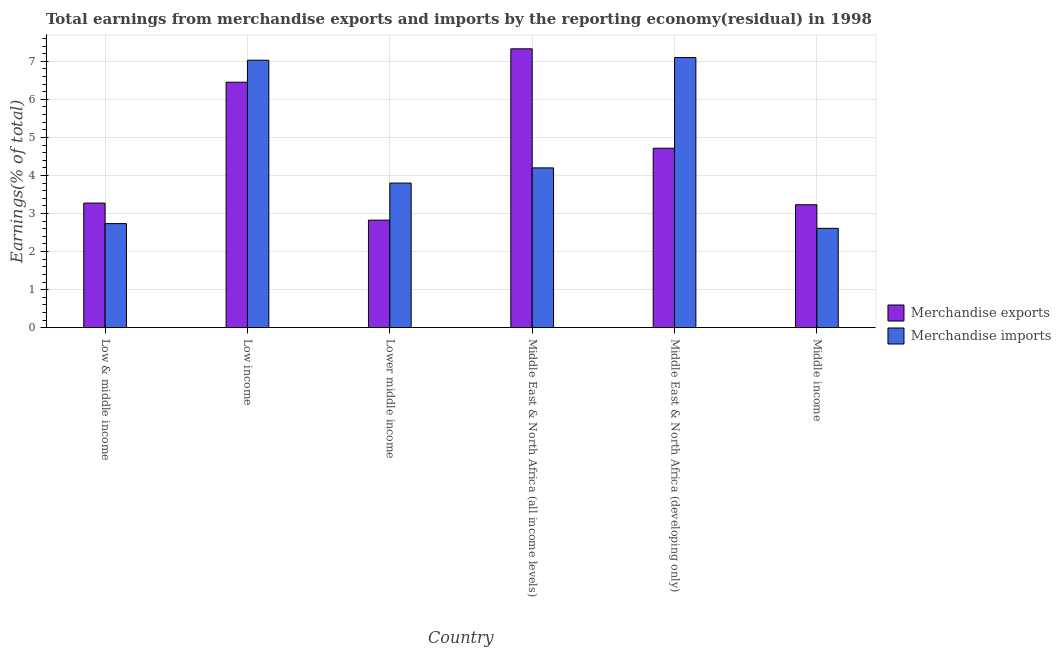How many different coloured bars are there?
Your answer should be very brief. 2. How many groups of bars are there?
Give a very brief answer. 6. Are the number of bars on each tick of the X-axis equal?
Make the answer very short. Yes. How many bars are there on the 4th tick from the left?
Offer a terse response. 2. What is the label of the 3rd group of bars from the left?
Your answer should be very brief. Lower middle income. What is the earnings from merchandise imports in Lower middle income?
Keep it short and to the point. 3.8. Across all countries, what is the maximum earnings from merchandise exports?
Keep it short and to the point. 7.33. Across all countries, what is the minimum earnings from merchandise imports?
Offer a terse response. 2.61. In which country was the earnings from merchandise exports maximum?
Your answer should be very brief. Middle East & North Africa (all income levels). In which country was the earnings from merchandise exports minimum?
Give a very brief answer. Lower middle income. What is the total earnings from merchandise exports in the graph?
Make the answer very short. 27.82. What is the difference between the earnings from merchandise imports in Low income and that in Middle East & North Africa (developing only)?
Your response must be concise. -0.07. What is the difference between the earnings from merchandise imports in Low income and the earnings from merchandise exports in Low & middle income?
Provide a succinct answer. 3.75. What is the average earnings from merchandise imports per country?
Give a very brief answer. 4.58. What is the difference between the earnings from merchandise exports and earnings from merchandise imports in Middle East & North Africa (developing only)?
Provide a short and direct response. -2.38. In how many countries, is the earnings from merchandise exports greater than 0.2 %?
Offer a very short reply. 6. What is the ratio of the earnings from merchandise exports in Lower middle income to that in Middle East & North Africa (all income levels)?
Your response must be concise. 0.39. Is the difference between the earnings from merchandise imports in Lower middle income and Middle East & North Africa (all income levels) greater than the difference between the earnings from merchandise exports in Lower middle income and Middle East & North Africa (all income levels)?
Provide a short and direct response. Yes. What is the difference between the highest and the second highest earnings from merchandise exports?
Make the answer very short. 0.88. What is the difference between the highest and the lowest earnings from merchandise exports?
Keep it short and to the point. 4.5. In how many countries, is the earnings from merchandise imports greater than the average earnings from merchandise imports taken over all countries?
Provide a short and direct response. 2. Is the sum of the earnings from merchandise imports in Low income and Middle income greater than the maximum earnings from merchandise exports across all countries?
Your response must be concise. Yes. What does the 1st bar from the right in Middle income represents?
Offer a very short reply. Merchandise imports. How many bars are there?
Make the answer very short. 12. Are all the bars in the graph horizontal?
Provide a succinct answer. No. Are the values on the major ticks of Y-axis written in scientific E-notation?
Your response must be concise. No. Does the graph contain any zero values?
Offer a terse response. No. Does the graph contain grids?
Give a very brief answer. Yes. Where does the legend appear in the graph?
Provide a short and direct response. Center right. What is the title of the graph?
Your response must be concise. Total earnings from merchandise exports and imports by the reporting economy(residual) in 1998. Does "Secondary education" appear as one of the legend labels in the graph?
Provide a succinct answer. No. What is the label or title of the Y-axis?
Keep it short and to the point. Earnings(% of total). What is the Earnings(% of total) of Merchandise exports in Low & middle income?
Make the answer very short. 3.27. What is the Earnings(% of total) of Merchandise imports in Low & middle income?
Make the answer very short. 2.73. What is the Earnings(% of total) of Merchandise exports in Low income?
Your answer should be very brief. 6.45. What is the Earnings(% of total) of Merchandise imports in Low income?
Offer a terse response. 7.03. What is the Earnings(% of total) in Merchandise exports in Lower middle income?
Your answer should be compact. 2.83. What is the Earnings(% of total) of Merchandise imports in Lower middle income?
Ensure brevity in your answer.  3.8. What is the Earnings(% of total) in Merchandise exports in Middle East & North Africa (all income levels)?
Make the answer very short. 7.33. What is the Earnings(% of total) in Merchandise imports in Middle East & North Africa (all income levels)?
Provide a succinct answer. 4.2. What is the Earnings(% of total) of Merchandise exports in Middle East & North Africa (developing only)?
Your answer should be very brief. 4.72. What is the Earnings(% of total) in Merchandise imports in Middle East & North Africa (developing only)?
Ensure brevity in your answer.  7.1. What is the Earnings(% of total) of Merchandise exports in Middle income?
Your answer should be compact. 3.23. What is the Earnings(% of total) in Merchandise imports in Middle income?
Offer a terse response. 2.61. Across all countries, what is the maximum Earnings(% of total) of Merchandise exports?
Provide a succinct answer. 7.33. Across all countries, what is the maximum Earnings(% of total) in Merchandise imports?
Your answer should be compact. 7.1. Across all countries, what is the minimum Earnings(% of total) in Merchandise exports?
Make the answer very short. 2.83. Across all countries, what is the minimum Earnings(% of total) of Merchandise imports?
Your answer should be compact. 2.61. What is the total Earnings(% of total) in Merchandise exports in the graph?
Provide a short and direct response. 27.82. What is the total Earnings(% of total) of Merchandise imports in the graph?
Your response must be concise. 27.47. What is the difference between the Earnings(% of total) in Merchandise exports in Low & middle income and that in Low income?
Keep it short and to the point. -3.18. What is the difference between the Earnings(% of total) of Merchandise imports in Low & middle income and that in Low income?
Give a very brief answer. -4.29. What is the difference between the Earnings(% of total) in Merchandise exports in Low & middle income and that in Lower middle income?
Your response must be concise. 0.45. What is the difference between the Earnings(% of total) of Merchandise imports in Low & middle income and that in Lower middle income?
Keep it short and to the point. -1.07. What is the difference between the Earnings(% of total) in Merchandise exports in Low & middle income and that in Middle East & North Africa (all income levels)?
Your answer should be very brief. -4.05. What is the difference between the Earnings(% of total) of Merchandise imports in Low & middle income and that in Middle East & North Africa (all income levels)?
Offer a very short reply. -1.46. What is the difference between the Earnings(% of total) in Merchandise exports in Low & middle income and that in Middle East & North Africa (developing only)?
Your answer should be very brief. -1.44. What is the difference between the Earnings(% of total) of Merchandise imports in Low & middle income and that in Middle East & North Africa (developing only)?
Your answer should be very brief. -4.36. What is the difference between the Earnings(% of total) in Merchandise exports in Low & middle income and that in Middle income?
Ensure brevity in your answer.  0.04. What is the difference between the Earnings(% of total) of Merchandise imports in Low & middle income and that in Middle income?
Give a very brief answer. 0.12. What is the difference between the Earnings(% of total) in Merchandise exports in Low income and that in Lower middle income?
Provide a succinct answer. 3.63. What is the difference between the Earnings(% of total) of Merchandise imports in Low income and that in Lower middle income?
Give a very brief answer. 3.23. What is the difference between the Earnings(% of total) of Merchandise exports in Low income and that in Middle East & North Africa (all income levels)?
Ensure brevity in your answer.  -0.88. What is the difference between the Earnings(% of total) in Merchandise imports in Low income and that in Middle East & North Africa (all income levels)?
Keep it short and to the point. 2.83. What is the difference between the Earnings(% of total) of Merchandise exports in Low income and that in Middle East & North Africa (developing only)?
Your answer should be compact. 1.74. What is the difference between the Earnings(% of total) of Merchandise imports in Low income and that in Middle East & North Africa (developing only)?
Keep it short and to the point. -0.07. What is the difference between the Earnings(% of total) of Merchandise exports in Low income and that in Middle income?
Your answer should be very brief. 3.22. What is the difference between the Earnings(% of total) in Merchandise imports in Low income and that in Middle income?
Provide a short and direct response. 4.42. What is the difference between the Earnings(% of total) in Merchandise exports in Lower middle income and that in Middle East & North Africa (all income levels)?
Your answer should be very brief. -4.5. What is the difference between the Earnings(% of total) of Merchandise imports in Lower middle income and that in Middle East & North Africa (all income levels)?
Your response must be concise. -0.4. What is the difference between the Earnings(% of total) of Merchandise exports in Lower middle income and that in Middle East & North Africa (developing only)?
Give a very brief answer. -1.89. What is the difference between the Earnings(% of total) of Merchandise imports in Lower middle income and that in Middle East & North Africa (developing only)?
Offer a very short reply. -3.3. What is the difference between the Earnings(% of total) of Merchandise exports in Lower middle income and that in Middle income?
Keep it short and to the point. -0.41. What is the difference between the Earnings(% of total) in Merchandise imports in Lower middle income and that in Middle income?
Your response must be concise. 1.19. What is the difference between the Earnings(% of total) of Merchandise exports in Middle East & North Africa (all income levels) and that in Middle East & North Africa (developing only)?
Offer a terse response. 2.61. What is the difference between the Earnings(% of total) of Merchandise imports in Middle East & North Africa (all income levels) and that in Middle East & North Africa (developing only)?
Ensure brevity in your answer.  -2.9. What is the difference between the Earnings(% of total) in Merchandise exports in Middle East & North Africa (all income levels) and that in Middle income?
Your answer should be very brief. 4.1. What is the difference between the Earnings(% of total) in Merchandise imports in Middle East & North Africa (all income levels) and that in Middle income?
Your answer should be very brief. 1.59. What is the difference between the Earnings(% of total) of Merchandise exports in Middle East & North Africa (developing only) and that in Middle income?
Your answer should be compact. 1.48. What is the difference between the Earnings(% of total) in Merchandise imports in Middle East & North Africa (developing only) and that in Middle income?
Your response must be concise. 4.49. What is the difference between the Earnings(% of total) of Merchandise exports in Low & middle income and the Earnings(% of total) of Merchandise imports in Low income?
Make the answer very short. -3.75. What is the difference between the Earnings(% of total) in Merchandise exports in Low & middle income and the Earnings(% of total) in Merchandise imports in Lower middle income?
Ensure brevity in your answer.  -0.53. What is the difference between the Earnings(% of total) of Merchandise exports in Low & middle income and the Earnings(% of total) of Merchandise imports in Middle East & North Africa (all income levels)?
Keep it short and to the point. -0.92. What is the difference between the Earnings(% of total) of Merchandise exports in Low & middle income and the Earnings(% of total) of Merchandise imports in Middle East & North Africa (developing only)?
Your answer should be very brief. -3.82. What is the difference between the Earnings(% of total) of Merchandise exports in Low & middle income and the Earnings(% of total) of Merchandise imports in Middle income?
Give a very brief answer. 0.66. What is the difference between the Earnings(% of total) in Merchandise exports in Low income and the Earnings(% of total) in Merchandise imports in Lower middle income?
Your answer should be compact. 2.65. What is the difference between the Earnings(% of total) in Merchandise exports in Low income and the Earnings(% of total) in Merchandise imports in Middle East & North Africa (all income levels)?
Make the answer very short. 2.25. What is the difference between the Earnings(% of total) in Merchandise exports in Low income and the Earnings(% of total) in Merchandise imports in Middle East & North Africa (developing only)?
Give a very brief answer. -0.65. What is the difference between the Earnings(% of total) in Merchandise exports in Low income and the Earnings(% of total) in Merchandise imports in Middle income?
Offer a very short reply. 3.84. What is the difference between the Earnings(% of total) in Merchandise exports in Lower middle income and the Earnings(% of total) in Merchandise imports in Middle East & North Africa (all income levels)?
Give a very brief answer. -1.37. What is the difference between the Earnings(% of total) in Merchandise exports in Lower middle income and the Earnings(% of total) in Merchandise imports in Middle East & North Africa (developing only)?
Keep it short and to the point. -4.27. What is the difference between the Earnings(% of total) in Merchandise exports in Lower middle income and the Earnings(% of total) in Merchandise imports in Middle income?
Keep it short and to the point. 0.22. What is the difference between the Earnings(% of total) in Merchandise exports in Middle East & North Africa (all income levels) and the Earnings(% of total) in Merchandise imports in Middle East & North Africa (developing only)?
Your answer should be compact. 0.23. What is the difference between the Earnings(% of total) in Merchandise exports in Middle East & North Africa (all income levels) and the Earnings(% of total) in Merchandise imports in Middle income?
Make the answer very short. 4.72. What is the difference between the Earnings(% of total) of Merchandise exports in Middle East & North Africa (developing only) and the Earnings(% of total) of Merchandise imports in Middle income?
Offer a terse response. 2.1. What is the average Earnings(% of total) in Merchandise exports per country?
Give a very brief answer. 4.64. What is the average Earnings(% of total) in Merchandise imports per country?
Give a very brief answer. 4.58. What is the difference between the Earnings(% of total) of Merchandise exports and Earnings(% of total) of Merchandise imports in Low & middle income?
Ensure brevity in your answer.  0.54. What is the difference between the Earnings(% of total) in Merchandise exports and Earnings(% of total) in Merchandise imports in Low income?
Make the answer very short. -0.58. What is the difference between the Earnings(% of total) in Merchandise exports and Earnings(% of total) in Merchandise imports in Lower middle income?
Keep it short and to the point. -0.97. What is the difference between the Earnings(% of total) of Merchandise exports and Earnings(% of total) of Merchandise imports in Middle East & North Africa (all income levels)?
Provide a succinct answer. 3.13. What is the difference between the Earnings(% of total) of Merchandise exports and Earnings(% of total) of Merchandise imports in Middle East & North Africa (developing only)?
Give a very brief answer. -2.38. What is the difference between the Earnings(% of total) of Merchandise exports and Earnings(% of total) of Merchandise imports in Middle income?
Provide a short and direct response. 0.62. What is the ratio of the Earnings(% of total) in Merchandise exports in Low & middle income to that in Low income?
Your response must be concise. 0.51. What is the ratio of the Earnings(% of total) in Merchandise imports in Low & middle income to that in Low income?
Give a very brief answer. 0.39. What is the ratio of the Earnings(% of total) of Merchandise exports in Low & middle income to that in Lower middle income?
Ensure brevity in your answer.  1.16. What is the ratio of the Earnings(% of total) in Merchandise imports in Low & middle income to that in Lower middle income?
Your response must be concise. 0.72. What is the ratio of the Earnings(% of total) in Merchandise exports in Low & middle income to that in Middle East & North Africa (all income levels)?
Provide a short and direct response. 0.45. What is the ratio of the Earnings(% of total) of Merchandise imports in Low & middle income to that in Middle East & North Africa (all income levels)?
Offer a very short reply. 0.65. What is the ratio of the Earnings(% of total) in Merchandise exports in Low & middle income to that in Middle East & North Africa (developing only)?
Provide a succinct answer. 0.69. What is the ratio of the Earnings(% of total) of Merchandise imports in Low & middle income to that in Middle East & North Africa (developing only)?
Keep it short and to the point. 0.39. What is the ratio of the Earnings(% of total) in Merchandise exports in Low & middle income to that in Middle income?
Keep it short and to the point. 1.01. What is the ratio of the Earnings(% of total) in Merchandise imports in Low & middle income to that in Middle income?
Offer a terse response. 1.05. What is the ratio of the Earnings(% of total) of Merchandise exports in Low income to that in Lower middle income?
Offer a very short reply. 2.28. What is the ratio of the Earnings(% of total) in Merchandise imports in Low income to that in Lower middle income?
Ensure brevity in your answer.  1.85. What is the ratio of the Earnings(% of total) of Merchandise exports in Low income to that in Middle East & North Africa (all income levels)?
Ensure brevity in your answer.  0.88. What is the ratio of the Earnings(% of total) of Merchandise imports in Low income to that in Middle East & North Africa (all income levels)?
Your response must be concise. 1.67. What is the ratio of the Earnings(% of total) in Merchandise exports in Low income to that in Middle East & North Africa (developing only)?
Provide a succinct answer. 1.37. What is the ratio of the Earnings(% of total) in Merchandise imports in Low income to that in Middle East & North Africa (developing only)?
Keep it short and to the point. 0.99. What is the ratio of the Earnings(% of total) of Merchandise exports in Low income to that in Middle income?
Give a very brief answer. 2. What is the ratio of the Earnings(% of total) in Merchandise imports in Low income to that in Middle income?
Ensure brevity in your answer.  2.69. What is the ratio of the Earnings(% of total) of Merchandise exports in Lower middle income to that in Middle East & North Africa (all income levels)?
Provide a succinct answer. 0.39. What is the ratio of the Earnings(% of total) of Merchandise imports in Lower middle income to that in Middle East & North Africa (all income levels)?
Give a very brief answer. 0.91. What is the ratio of the Earnings(% of total) in Merchandise exports in Lower middle income to that in Middle East & North Africa (developing only)?
Your answer should be compact. 0.6. What is the ratio of the Earnings(% of total) in Merchandise imports in Lower middle income to that in Middle East & North Africa (developing only)?
Your answer should be very brief. 0.54. What is the ratio of the Earnings(% of total) of Merchandise exports in Lower middle income to that in Middle income?
Offer a very short reply. 0.87. What is the ratio of the Earnings(% of total) of Merchandise imports in Lower middle income to that in Middle income?
Give a very brief answer. 1.46. What is the ratio of the Earnings(% of total) in Merchandise exports in Middle East & North Africa (all income levels) to that in Middle East & North Africa (developing only)?
Ensure brevity in your answer.  1.55. What is the ratio of the Earnings(% of total) in Merchandise imports in Middle East & North Africa (all income levels) to that in Middle East & North Africa (developing only)?
Offer a very short reply. 0.59. What is the ratio of the Earnings(% of total) of Merchandise exports in Middle East & North Africa (all income levels) to that in Middle income?
Your answer should be compact. 2.27. What is the ratio of the Earnings(% of total) of Merchandise imports in Middle East & North Africa (all income levels) to that in Middle income?
Your answer should be compact. 1.61. What is the ratio of the Earnings(% of total) of Merchandise exports in Middle East & North Africa (developing only) to that in Middle income?
Provide a short and direct response. 1.46. What is the ratio of the Earnings(% of total) of Merchandise imports in Middle East & North Africa (developing only) to that in Middle income?
Give a very brief answer. 2.72. What is the difference between the highest and the second highest Earnings(% of total) of Merchandise exports?
Give a very brief answer. 0.88. What is the difference between the highest and the second highest Earnings(% of total) in Merchandise imports?
Keep it short and to the point. 0.07. What is the difference between the highest and the lowest Earnings(% of total) of Merchandise exports?
Provide a short and direct response. 4.5. What is the difference between the highest and the lowest Earnings(% of total) of Merchandise imports?
Offer a terse response. 4.49. 